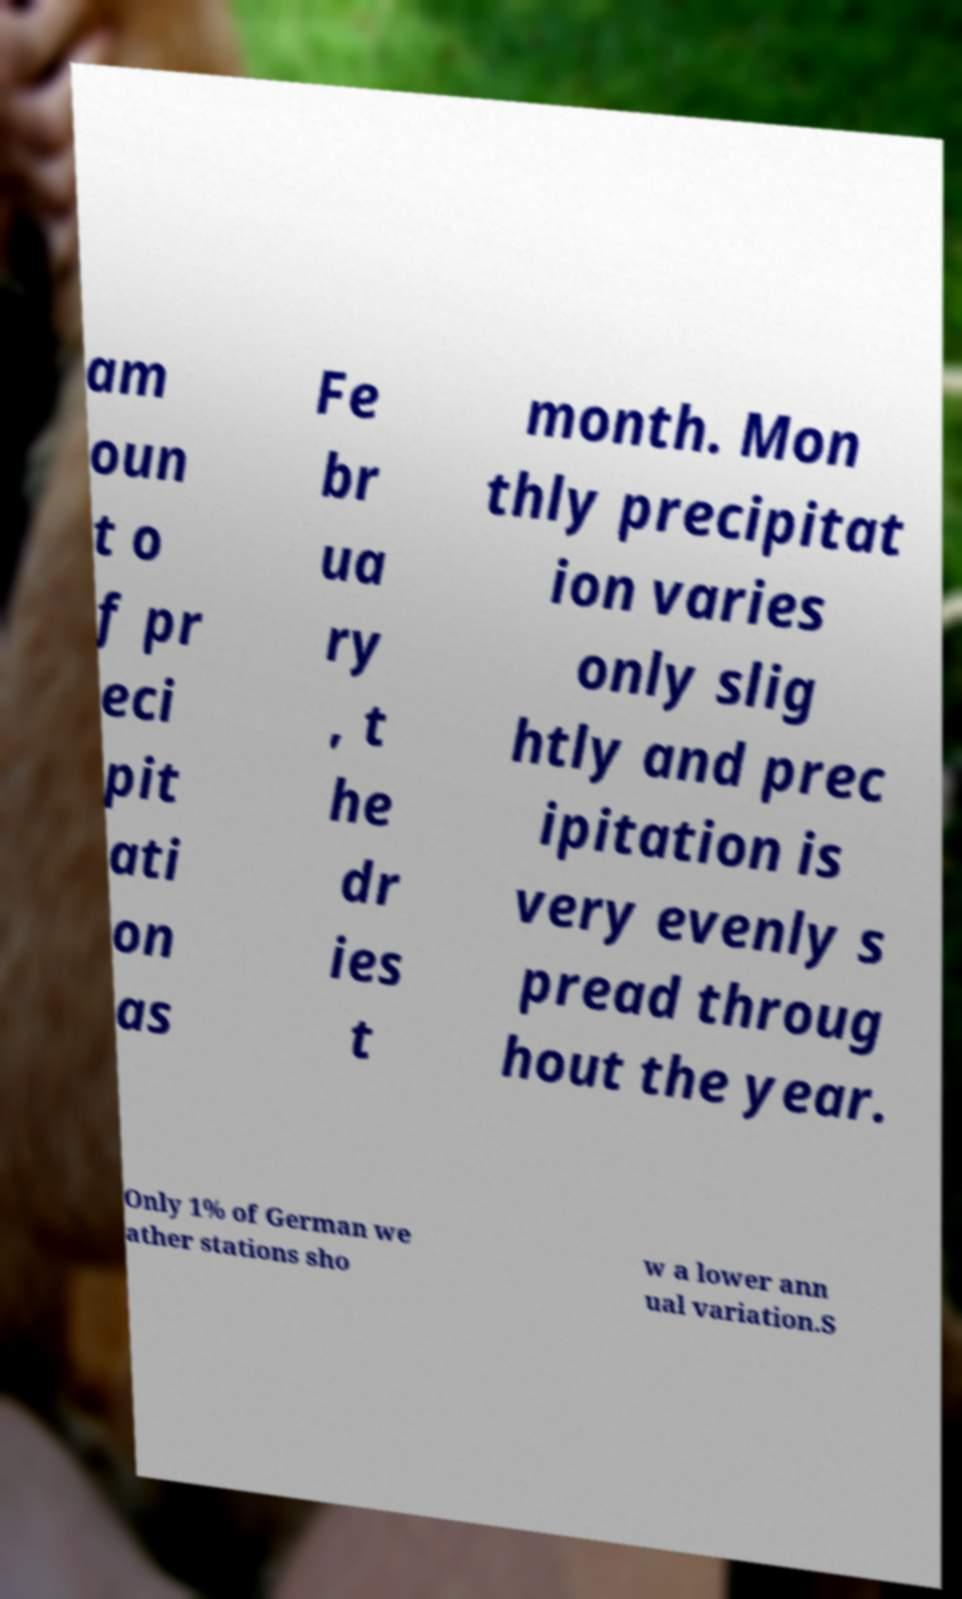Could you assist in decoding the text presented in this image and type it out clearly? am oun t o f pr eci pit ati on as Fe br ua ry , t he dr ies t month. Mon thly precipitat ion varies only slig htly and prec ipitation is very evenly s pread throug hout the year. Only 1% of German we ather stations sho w a lower ann ual variation.S 